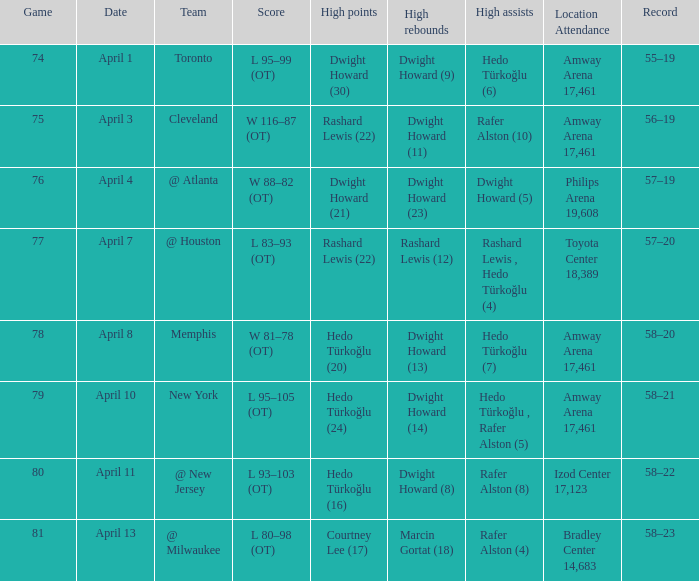What was the score in game 81? L 80–98 (OT). 